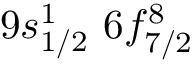<formula> <loc_0><loc_0><loc_500><loc_500>9 s _ { 1 / 2 } ^ { 1 } \, 6 f _ { 7 / 2 } ^ { 8 }</formula> 